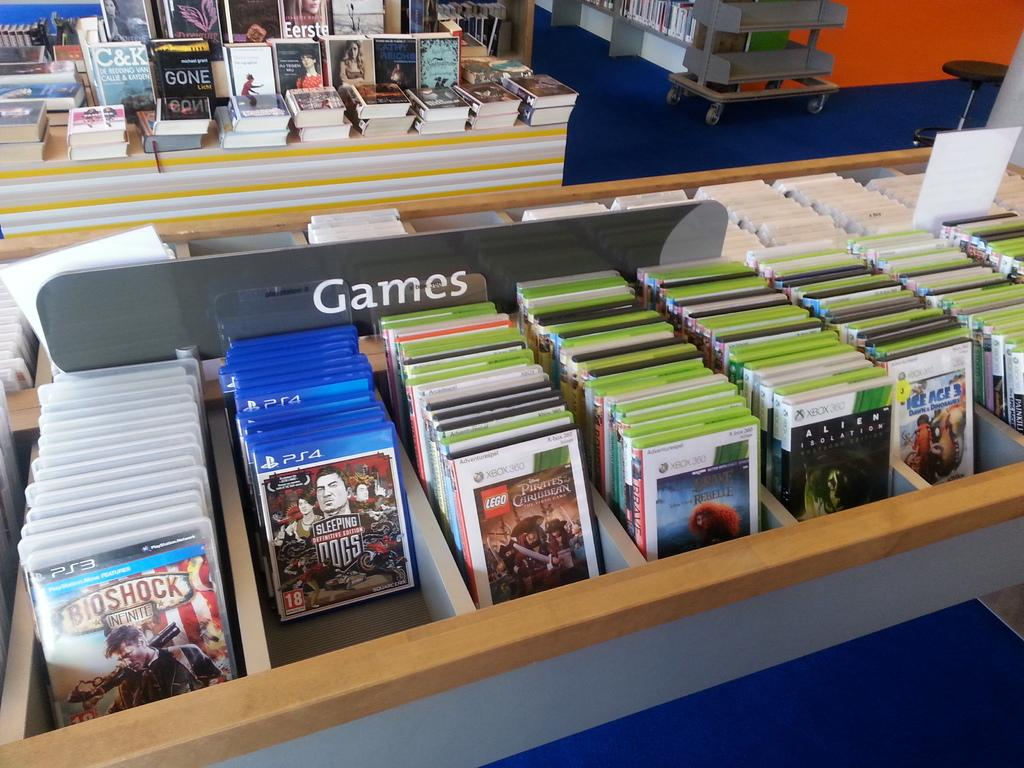<image>
Describe the image concisely. Playstation and xbox games are placed in a bin. 